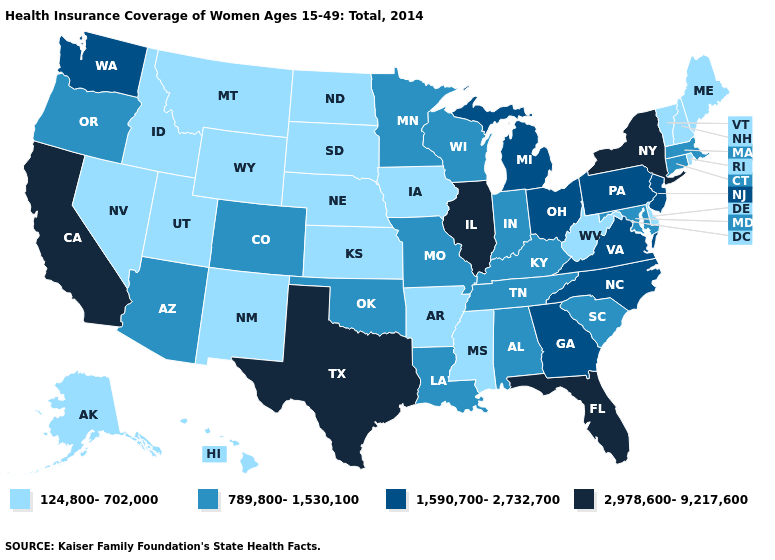Does the first symbol in the legend represent the smallest category?
Quick response, please. Yes. Among the states that border North Dakota , does South Dakota have the lowest value?
Short answer required. Yes. Name the states that have a value in the range 1,590,700-2,732,700?
Be succinct. Georgia, Michigan, New Jersey, North Carolina, Ohio, Pennsylvania, Virginia, Washington. Among the states that border Kentucky , which have the highest value?
Short answer required. Illinois. Name the states that have a value in the range 1,590,700-2,732,700?
Short answer required. Georgia, Michigan, New Jersey, North Carolina, Ohio, Pennsylvania, Virginia, Washington. Which states have the highest value in the USA?
Concise answer only. California, Florida, Illinois, New York, Texas. What is the highest value in states that border Maryland?
Give a very brief answer. 1,590,700-2,732,700. Among the states that border Connecticut , does Rhode Island have the lowest value?
Write a very short answer. Yes. What is the value of Louisiana?
Write a very short answer. 789,800-1,530,100. Does Virginia have the highest value in the USA?
Write a very short answer. No. Which states hav the highest value in the MidWest?
Keep it brief. Illinois. Does New York have the same value as Rhode Island?
Quick response, please. No. What is the value of Idaho?
Quick response, please. 124,800-702,000. What is the value of Vermont?
Answer briefly. 124,800-702,000. Does California have the highest value in the West?
Quick response, please. Yes. 